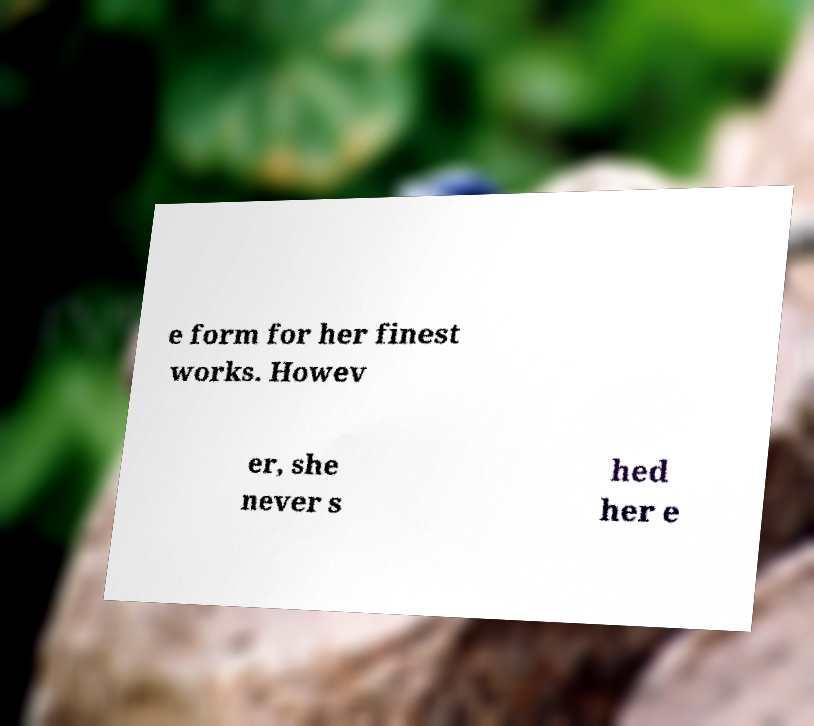Could you extract and type out the text from this image? e form for her finest works. Howev er, she never s hed her e 